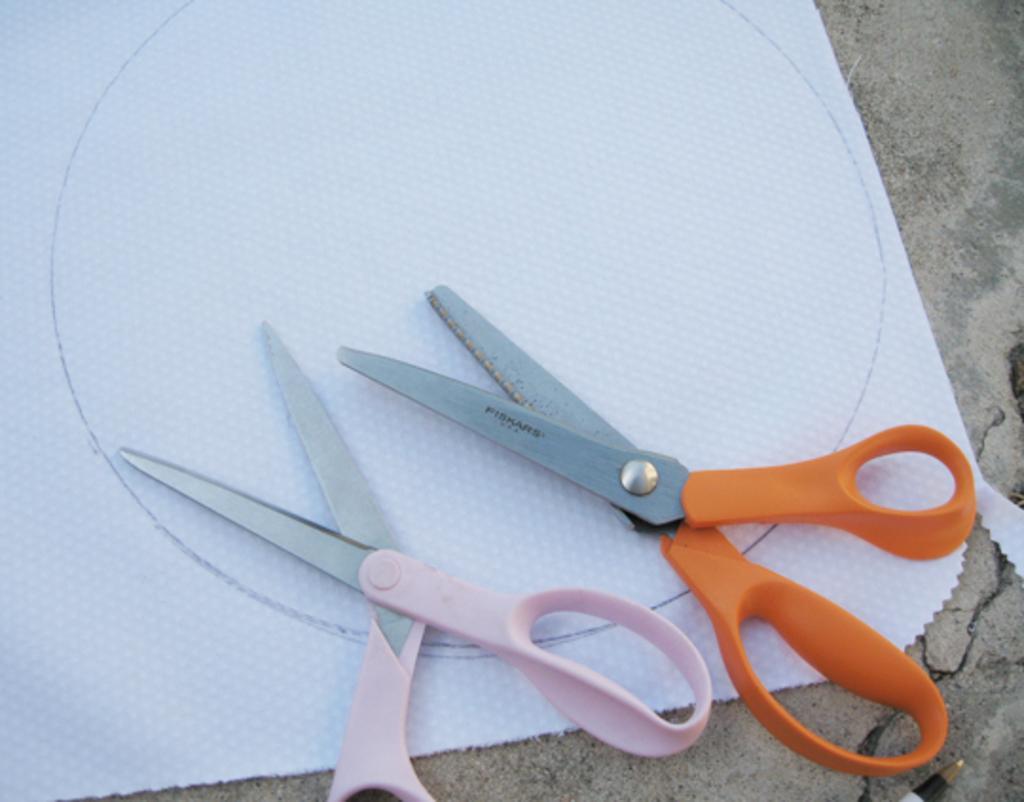Can you describe this image briefly? In this picture I can observe two scissors placed on the paper. These scissors are in pink and orange colors. 